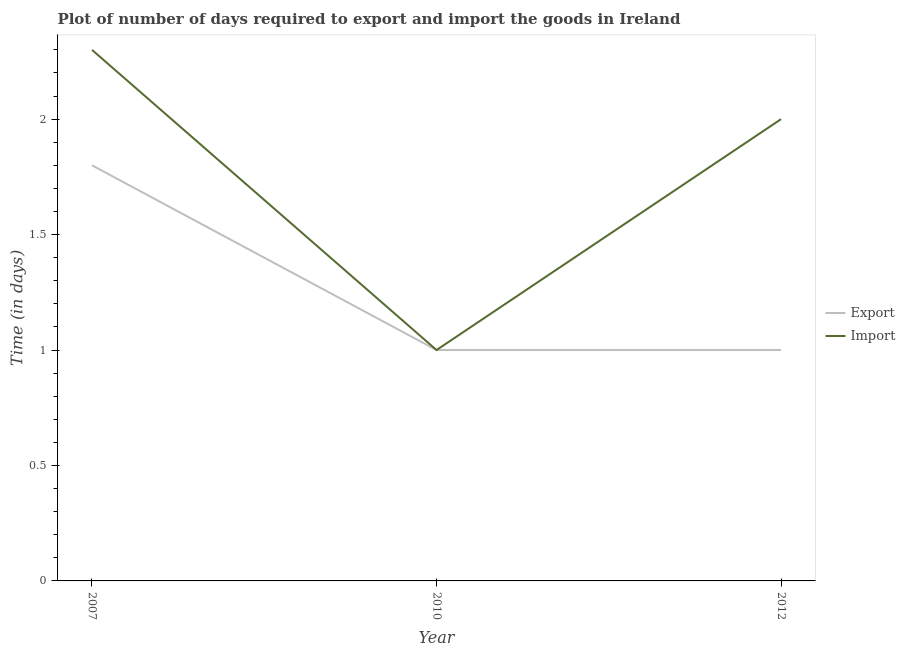How many different coloured lines are there?
Offer a terse response. 2. What is the time required to export in 2012?
Provide a short and direct response. 1. Across all years, what is the maximum time required to import?
Your response must be concise. 2.3. Across all years, what is the minimum time required to export?
Give a very brief answer. 1. In which year was the time required to export minimum?
Your answer should be very brief. 2010. What is the difference between the time required to export in 2012 and the time required to import in 2010?
Provide a short and direct response. 0. What is the average time required to import per year?
Your response must be concise. 1.77. In the year 2010, what is the difference between the time required to export and time required to import?
Your answer should be compact. 0. In how many years, is the time required to import greater than 0.5 days?
Offer a very short reply. 3. What is the ratio of the time required to import in 2007 to that in 2012?
Ensure brevity in your answer.  1.15. What is the difference between the highest and the lowest time required to export?
Your answer should be compact. 0.8. In how many years, is the time required to export greater than the average time required to export taken over all years?
Provide a short and direct response. 1. Does the time required to import monotonically increase over the years?
Make the answer very short. No. How many years are there in the graph?
Make the answer very short. 3. What is the difference between two consecutive major ticks on the Y-axis?
Ensure brevity in your answer.  0.5. Does the graph contain any zero values?
Your answer should be very brief. No. How many legend labels are there?
Your response must be concise. 2. What is the title of the graph?
Offer a very short reply. Plot of number of days required to export and import the goods in Ireland. Does "Pregnant women" appear as one of the legend labels in the graph?
Provide a short and direct response. No. What is the label or title of the Y-axis?
Your answer should be compact. Time (in days). What is the Time (in days) in Import in 2007?
Ensure brevity in your answer.  2.3. What is the Time (in days) of Export in 2010?
Offer a terse response. 1. What is the Time (in days) of Export in 2012?
Offer a very short reply. 1. What is the Time (in days) of Import in 2012?
Give a very brief answer. 2. Across all years, what is the minimum Time (in days) of Export?
Ensure brevity in your answer.  1. Across all years, what is the minimum Time (in days) in Import?
Give a very brief answer. 1. What is the total Time (in days) in Export in the graph?
Give a very brief answer. 3.8. What is the difference between the Time (in days) in Import in 2007 and that in 2010?
Your answer should be very brief. 1.3. What is the difference between the Time (in days) in Import in 2007 and that in 2012?
Provide a succinct answer. 0.3. What is the difference between the Time (in days) of Export in 2010 and that in 2012?
Offer a terse response. 0. What is the difference between the Time (in days) of Import in 2010 and that in 2012?
Offer a very short reply. -1. What is the difference between the Time (in days) of Export in 2007 and the Time (in days) of Import in 2010?
Offer a very short reply. 0.8. What is the difference between the Time (in days) of Export in 2010 and the Time (in days) of Import in 2012?
Ensure brevity in your answer.  -1. What is the average Time (in days) of Export per year?
Offer a terse response. 1.27. What is the average Time (in days) in Import per year?
Your response must be concise. 1.77. In the year 2010, what is the difference between the Time (in days) of Export and Time (in days) of Import?
Your response must be concise. 0. In the year 2012, what is the difference between the Time (in days) in Export and Time (in days) in Import?
Make the answer very short. -1. What is the ratio of the Time (in days) of Import in 2007 to that in 2012?
Ensure brevity in your answer.  1.15. What is the ratio of the Time (in days) in Export in 2010 to that in 2012?
Give a very brief answer. 1. What is the difference between the highest and the second highest Time (in days) of Export?
Make the answer very short. 0.8. 